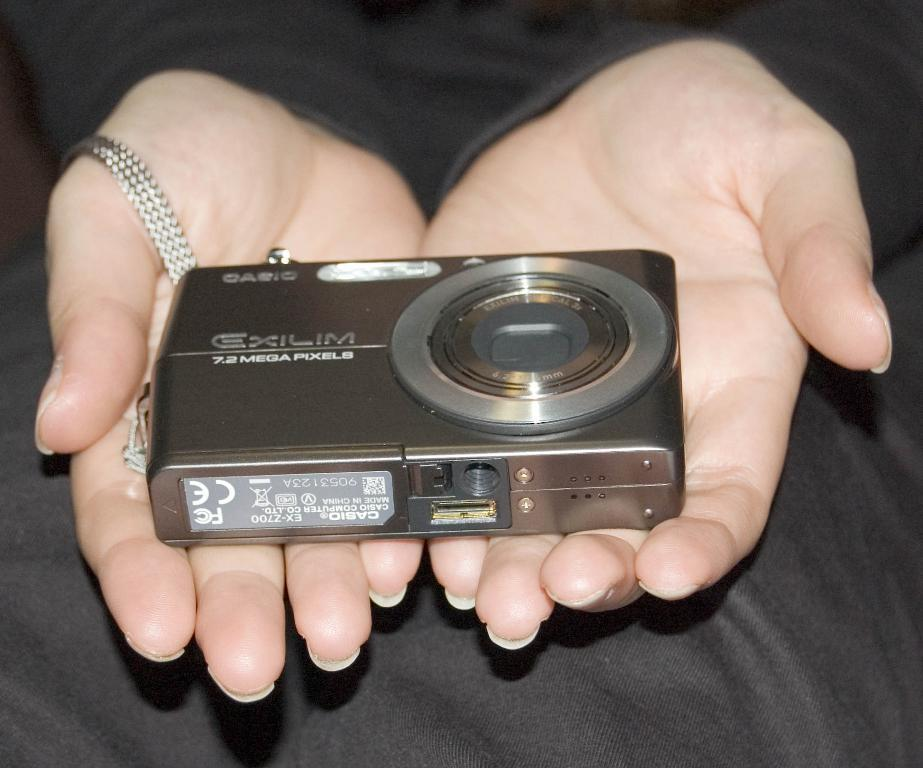What object is being held by a person in the image? There is a camera in the image, and it is being held by a person. What can be inferred about the person's activity in the image? The person is likely taking a photograph, given that they are holding a camera. How would you describe the background of the image? The background of the image is blurred. What emotion is the person holding the camera feeling in the image? There is no information about the person's emotions in the image, so it cannot be determined. 